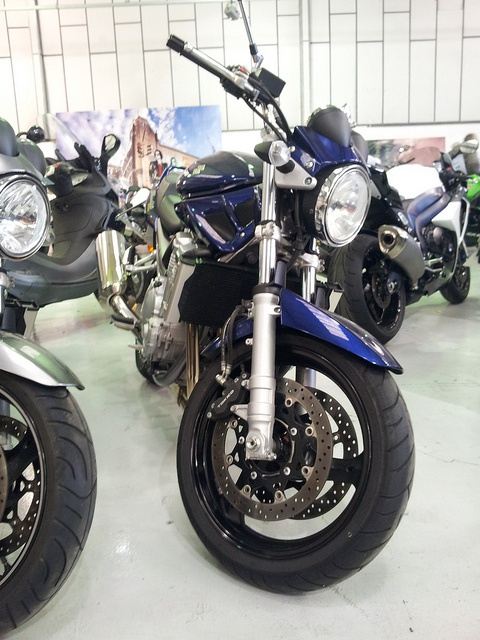Describe the objects in this image and their specific colors. I can see motorcycle in white, black, gray, lightgray, and darkgray tones, motorcycle in white, black, gray, lightgray, and darkgray tones, and motorcycle in white, black, gray, and darkgray tones in this image. 